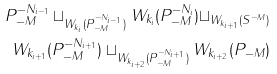<formula> <loc_0><loc_0><loc_500><loc_500>P _ { - M } ^ { - N _ { i - 1 } } \sqcup _ { W _ { k _ { i } } ( P _ { - M } ^ { - N _ { i - 1 } } ) } W _ { k _ { i } } ( P _ { - M } ^ { - N _ { i } } ) \sqcup _ { W _ { k _ { i + 1 } } ( S ^ { - M } ) } \\ W _ { k _ { i + 1 } } ( P _ { - M } ^ { - N _ { i + 1 } } ) \sqcup _ { W _ { k _ { i + 2 } } ( P _ { - M } ^ { - N _ { i + 1 } } ) } W _ { k _ { i + 2 } } ( P _ { - M } )</formula> 